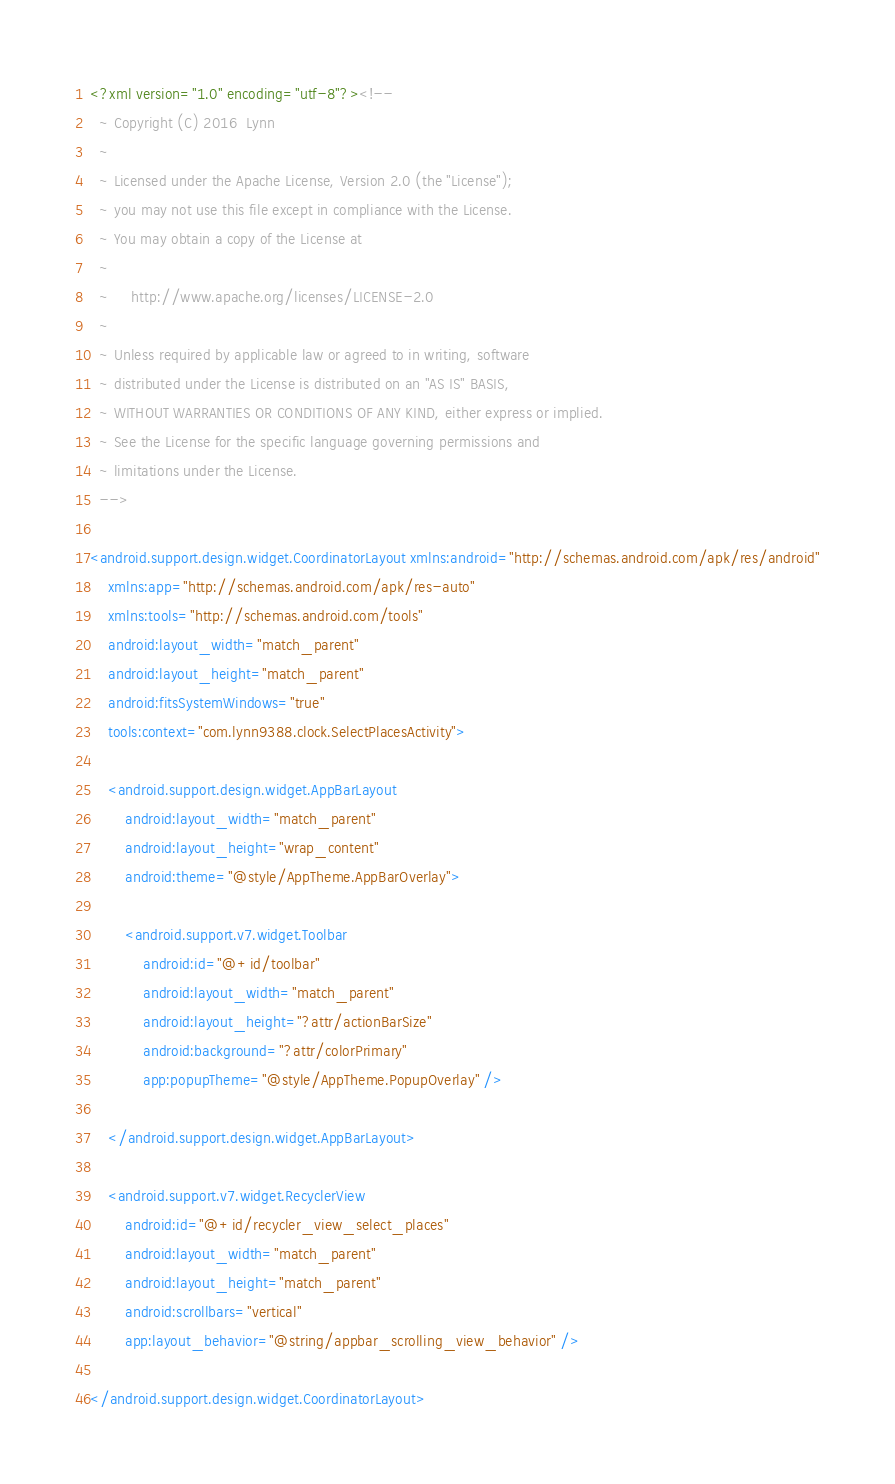Convert code to text. <code><loc_0><loc_0><loc_500><loc_500><_XML_><?xml version="1.0" encoding="utf-8"?><!--
  ~ Copyright (C) 2016  Lynn
  ~
  ~ Licensed under the Apache License, Version 2.0 (the "License");
  ~ you may not use this file except in compliance with the License.
  ~ You may obtain a copy of the License at
  ~
  ~     http://www.apache.org/licenses/LICENSE-2.0
  ~
  ~ Unless required by applicable law or agreed to in writing, software
  ~ distributed under the License is distributed on an "AS IS" BASIS,
  ~ WITHOUT WARRANTIES OR CONDITIONS OF ANY KIND, either express or implied.
  ~ See the License for the specific language governing permissions and
  ~ limitations under the License.
  -->

<android.support.design.widget.CoordinatorLayout xmlns:android="http://schemas.android.com/apk/res/android"
    xmlns:app="http://schemas.android.com/apk/res-auto"
    xmlns:tools="http://schemas.android.com/tools"
    android:layout_width="match_parent"
    android:layout_height="match_parent"
    android:fitsSystemWindows="true"
    tools:context="com.lynn9388.clock.SelectPlacesActivity">

    <android.support.design.widget.AppBarLayout
        android:layout_width="match_parent"
        android:layout_height="wrap_content"
        android:theme="@style/AppTheme.AppBarOverlay">

        <android.support.v7.widget.Toolbar
            android:id="@+id/toolbar"
            android:layout_width="match_parent"
            android:layout_height="?attr/actionBarSize"
            android:background="?attr/colorPrimary"
            app:popupTheme="@style/AppTheme.PopupOverlay" />

    </android.support.design.widget.AppBarLayout>

    <android.support.v7.widget.RecyclerView
        android:id="@+id/recycler_view_select_places"
        android:layout_width="match_parent"
        android:layout_height="match_parent"
        android:scrollbars="vertical"
        app:layout_behavior="@string/appbar_scrolling_view_behavior" />

</android.support.design.widget.CoordinatorLayout>
</code> 